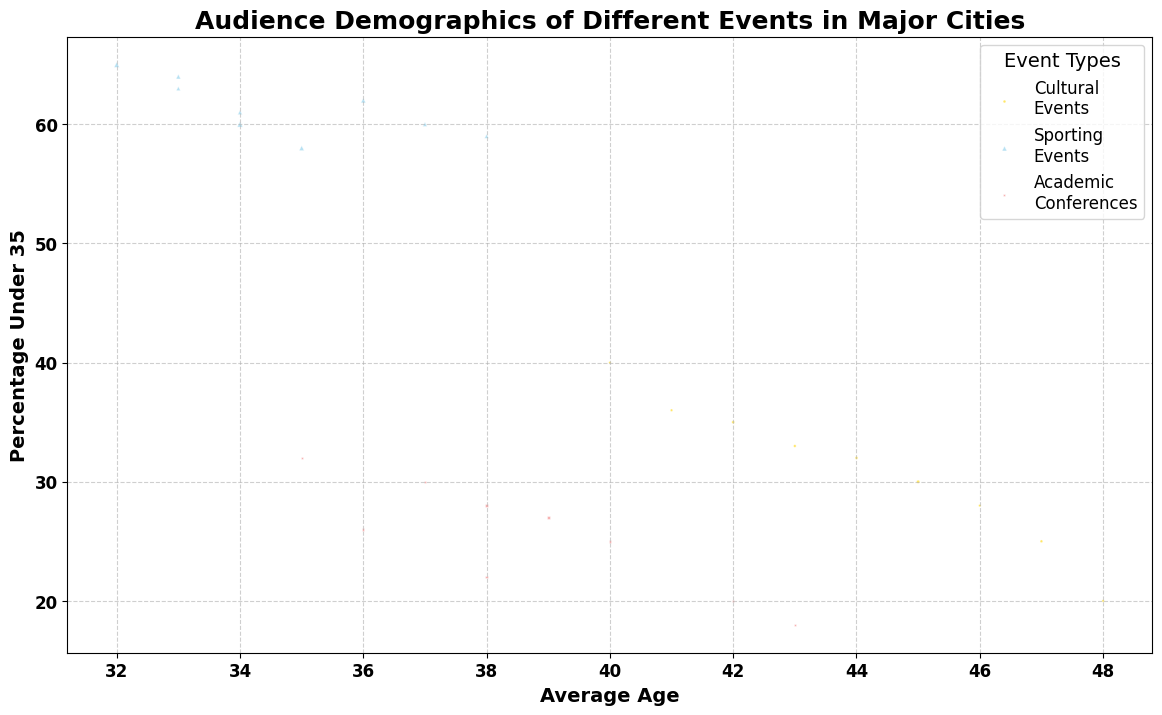What is the average age of audiences at Sporting Events in New York compared to Cultural Events in Los Angeles? The figure shows that the average age for Sporting Events in New York is 34, while the average age for Cultural Events in Los Angeles is 42.
Answer: New York Sporting Events: 34, Los Angeles Cultural Events: 42 Which city has the highest percentage of audiences under 35 at Cultural Events? By looking at the chart, San Diego has the highest percentage of audiences under 35 at Cultural Events, which is shown to be 40%.
Answer: San Diego Are there more females attending Cultural Events or Academic Conferences in Chicago? In the chart, the percentage of females attending Cultural Events in Chicago is 53%, while for Academic Conferences, it is 49%. Therefore, more females attend Cultural Events.
Answer: Cultural Events Which event type in Phoenix has the smallest bubble, and what does that indicate about audience size? The smallest bubble corresponds to Academic Conferences in Phoenix. Since bubble size represents audience size, this indicates that Academic Conferences in Phoenix have the smallest audience size among the three event types.
Answer: Academic Conferences What is the difference in average age between audiences attending Academic Conferences and Cultural Events in Houston? The chart shows that the average age for Academic Conferences in Houston is 42, and for Cultural Events, it is 47. The difference in average age is 47 - 42 = 5.
Answer: 5 Which event type in Los Angeles has a higher percentage of audiences under 35, and what might be the implications for event organizers? Sporting Events in Los Angeles have a higher percentage of audiences under 35, which is 65%. This suggests that Sporting Events are more popular among younger audiences, and event organizers might focus on marketing these events to younger demographics.
Answer: Sporting Events In Philadelphia, which event type has the largest female audience percentage, and what is that percentage? In the chart, Cultural Events in Philadelphia have the largest female audience percentage, which is 56%.
Answer: Cultural Events, 56% What is the visual difference in bubble size between Sporting Events and Academic Conferences in Dallas, and what does it indicate? The bubble for Sporting Events in Dallas is significantly larger than the bubble for Academic Conferences, indicating a much larger audience size for Sporting Events compared to Academic Conferences.
Answer: Sporting Events have a much larger audience Which event type in San Diego has audiences with the lowest average age, and what is this average age? The chart indicates that Academic Conferences in San Diego have the lowest average age, which is 35.
Answer: Academic Conferences, 35 Considering all cities, which event type generally seems to attract the highest percentage of audiences under 35? From the chart, Sporting Events consistently show the highest percentage of audiences under 35 across different cities, with percentages ranging from 58% to 65%.
Answer: Sporting Events 